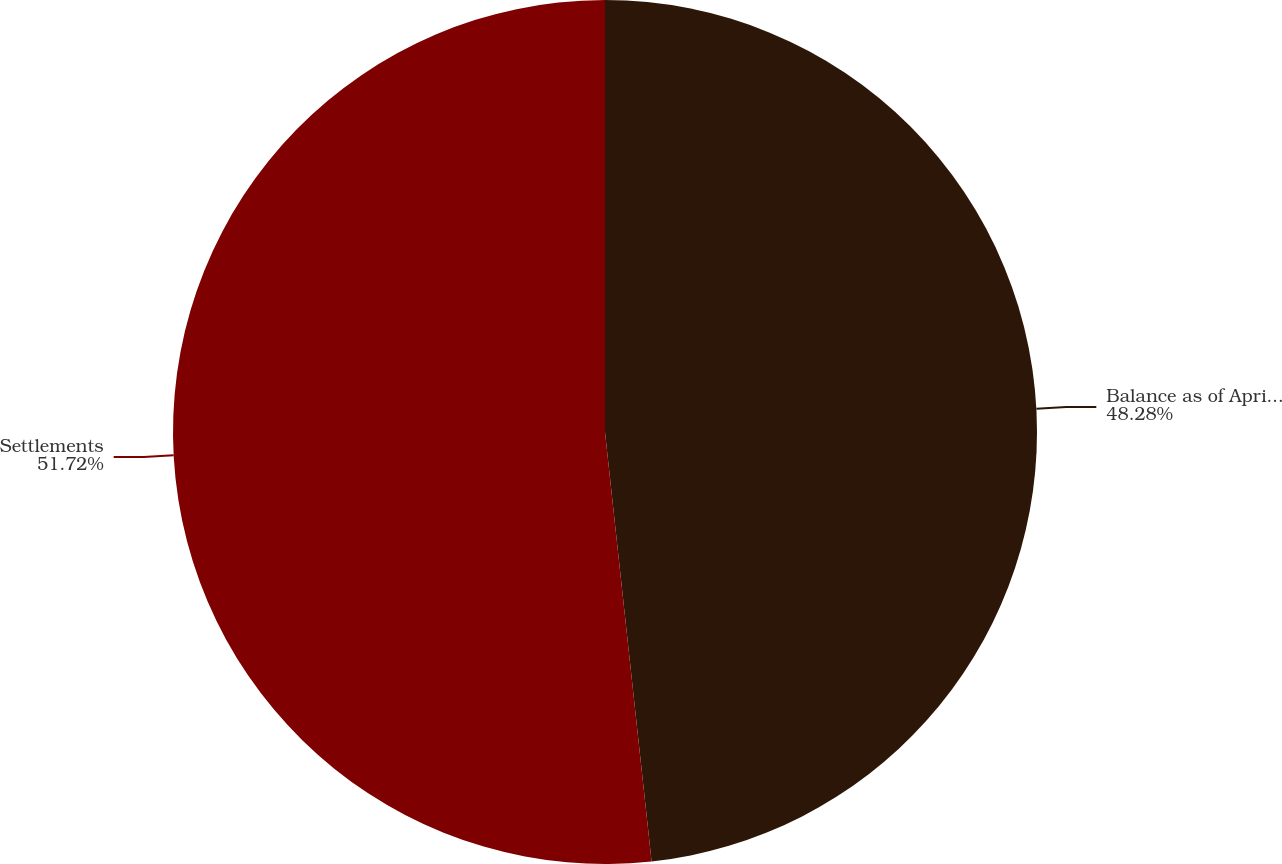Convert chart to OTSL. <chart><loc_0><loc_0><loc_500><loc_500><pie_chart><fcel>Balance as of April 26 2013<fcel>Settlements<nl><fcel>48.28%<fcel>51.72%<nl></chart> 